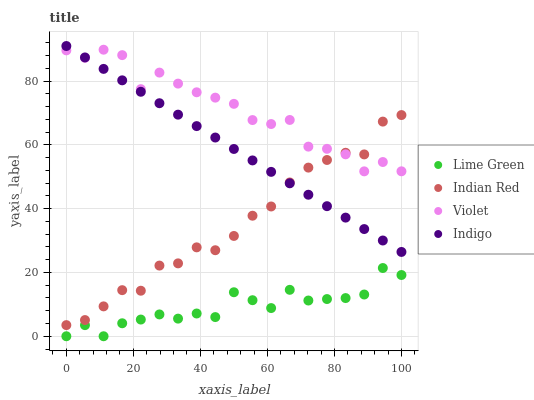Does Lime Green have the minimum area under the curve?
Answer yes or no. Yes. Does Violet have the maximum area under the curve?
Answer yes or no. Yes. Does Indian Red have the minimum area under the curve?
Answer yes or no. No. Does Indian Red have the maximum area under the curve?
Answer yes or no. No. Is Indigo the smoothest?
Answer yes or no. Yes. Is Violet the roughest?
Answer yes or no. Yes. Is Lime Green the smoothest?
Answer yes or no. No. Is Lime Green the roughest?
Answer yes or no. No. Does Lime Green have the lowest value?
Answer yes or no. Yes. Does Indian Red have the lowest value?
Answer yes or no. No. Does Indigo have the highest value?
Answer yes or no. Yes. Does Indian Red have the highest value?
Answer yes or no. No. Is Lime Green less than Violet?
Answer yes or no. Yes. Is Violet greater than Lime Green?
Answer yes or no. Yes. Does Indigo intersect Indian Red?
Answer yes or no. Yes. Is Indigo less than Indian Red?
Answer yes or no. No. Is Indigo greater than Indian Red?
Answer yes or no. No. Does Lime Green intersect Violet?
Answer yes or no. No. 